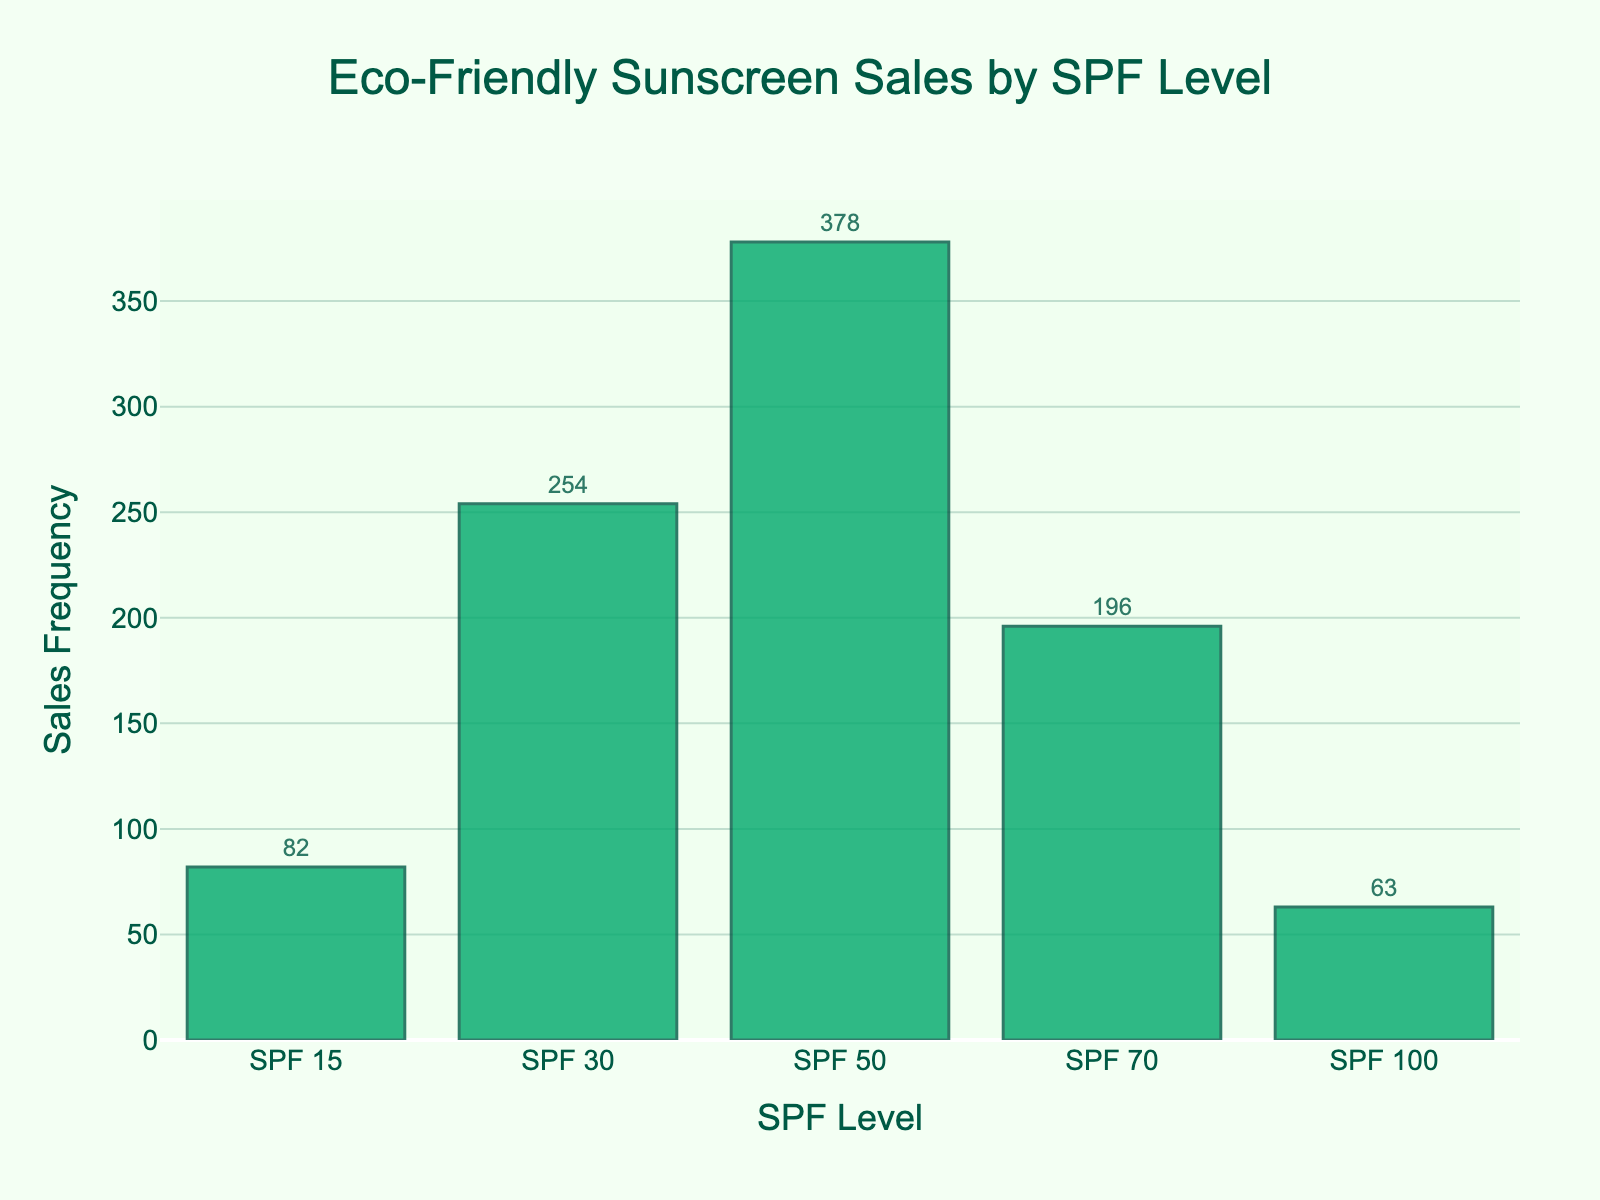What is the title of the figure? The title is always prominently displayed and describes the content or the purpose of the figure. Here, it reads "Eco-Friendly Sunscreen Sales by SPF Level".
Answer: Eco-Friendly Sunscreen Sales by SPF Level Which SPF level has the highest sales frequency? Observing the heights of the bars reveals which one is the tallest. Here, the SPF 50 bar is the tallest, indicating it has the highest sales frequency.
Answer: SPF 50 What is the sales frequency for SPF 30? Looking directly at the top of the SPF 30 bar and reading its value or text label reveals the sales frequency. Here, the value is 254.
Answer: 254 How many SPF levels are represented in the figure? Counting the individual bars in the histogram tells us how many SPF levels are shown. Here, there are five bars for SPF levels 15, 30, 50, 70, and 100.
Answer: 5 What is the total sales frequency for all SPF levels combined? Adding the sales frequencies of all bars (82 + 254 + 378 + 196 + 63) gives the total sales frequency: 973.
Answer: 973 Which SPF level has the lowest sales frequency? Observing the heights of the bars shows that the one for SPF 100 is the shortest, indicating the lowest sales frequency.
Answer: SPF 100 How much higher is the sales frequency for SPF 50 compared to SPF 15? Subtracting the sales frequency of SPF 15 (82) from that of SPF 50 (378) shows how much higher it is: 378 - 82 = 296.
Answer: 296 What is the average sales frequency for SPF levels greater than SPF 50? Adding the sales frequencies of SPF 70 and SPF 100 (196 + 63) and dividing by 2 gives the average: (196 + 63) / 2 = 129.5.
Answer: 129.5 Is the sales frequency of SPF 30 more than twice that of SPF 70? Comparing twice the sales frequency of SPF 70 (2 * 196 = 392) with that of SPF 30 (254) shows that SPF 30 is not more than twice that of SPF 70.
Answer: No Is the sales trend generally increasing or decreasing as the SPF level goes higher? Observing the heights of the bars across SPF levels shows a variation, not a consistent increase or decrease. SPF 50 has the highest sales, while SPF 100 and SPF 15 are on the lower end. The trend does not show a consistent direction.
Answer: Neither consistent increasing nor decreasing 